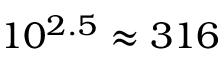Convert formula to latex. <formula><loc_0><loc_0><loc_500><loc_500>1 0 ^ { 2 . 5 } \approx 3 1 6</formula> 